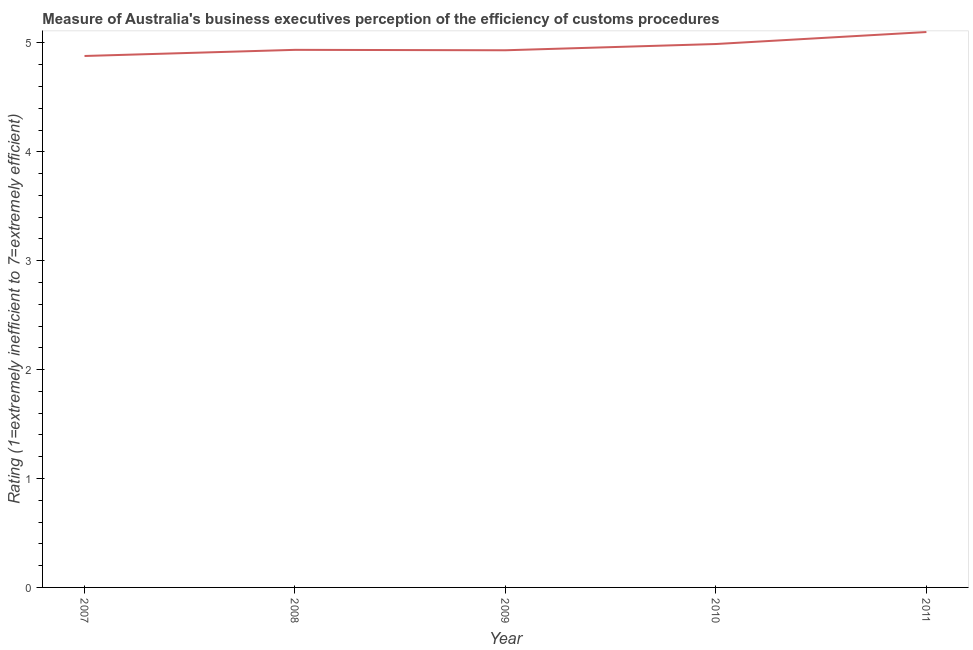What is the rating measuring burden of customs procedure in 2007?
Give a very brief answer. 4.88. Across all years, what is the minimum rating measuring burden of customs procedure?
Your answer should be very brief. 4.88. In which year was the rating measuring burden of customs procedure maximum?
Offer a very short reply. 2011. What is the sum of the rating measuring burden of customs procedure?
Make the answer very short. 24.84. What is the difference between the rating measuring burden of customs procedure in 2008 and 2010?
Your answer should be very brief. -0.05. What is the average rating measuring burden of customs procedure per year?
Provide a short and direct response. 4.97. What is the median rating measuring burden of customs procedure?
Make the answer very short. 4.94. In how many years, is the rating measuring burden of customs procedure greater than 0.6000000000000001 ?
Offer a very short reply. 5. Do a majority of the years between 2010 and 2008 (inclusive) have rating measuring burden of customs procedure greater than 2.8 ?
Give a very brief answer. No. What is the ratio of the rating measuring burden of customs procedure in 2008 to that in 2010?
Offer a terse response. 0.99. Is the rating measuring burden of customs procedure in 2009 less than that in 2011?
Provide a short and direct response. Yes. What is the difference between the highest and the second highest rating measuring burden of customs procedure?
Ensure brevity in your answer.  0.11. Is the sum of the rating measuring burden of customs procedure in 2007 and 2010 greater than the maximum rating measuring burden of customs procedure across all years?
Offer a terse response. Yes. What is the difference between the highest and the lowest rating measuring burden of customs procedure?
Your answer should be compact. 0.22. In how many years, is the rating measuring burden of customs procedure greater than the average rating measuring burden of customs procedure taken over all years?
Make the answer very short. 2. What is the difference between two consecutive major ticks on the Y-axis?
Offer a very short reply. 1. What is the title of the graph?
Your answer should be very brief. Measure of Australia's business executives perception of the efficiency of customs procedures. What is the label or title of the Y-axis?
Your response must be concise. Rating (1=extremely inefficient to 7=extremely efficient). What is the Rating (1=extremely inefficient to 7=extremely efficient) in 2007?
Make the answer very short. 4.88. What is the Rating (1=extremely inefficient to 7=extremely efficient) of 2008?
Offer a very short reply. 4.94. What is the Rating (1=extremely inefficient to 7=extremely efficient) in 2009?
Make the answer very short. 4.93. What is the Rating (1=extremely inefficient to 7=extremely efficient) in 2010?
Provide a short and direct response. 4.99. What is the difference between the Rating (1=extremely inefficient to 7=extremely efficient) in 2007 and 2008?
Offer a terse response. -0.06. What is the difference between the Rating (1=extremely inefficient to 7=extremely efficient) in 2007 and 2009?
Your response must be concise. -0.05. What is the difference between the Rating (1=extremely inefficient to 7=extremely efficient) in 2007 and 2010?
Offer a terse response. -0.11. What is the difference between the Rating (1=extremely inefficient to 7=extremely efficient) in 2007 and 2011?
Your answer should be compact. -0.22. What is the difference between the Rating (1=extremely inefficient to 7=extremely efficient) in 2008 and 2009?
Make the answer very short. 0. What is the difference between the Rating (1=extremely inefficient to 7=extremely efficient) in 2008 and 2010?
Your answer should be compact. -0.05. What is the difference between the Rating (1=extremely inefficient to 7=extremely efficient) in 2008 and 2011?
Keep it short and to the point. -0.16. What is the difference between the Rating (1=extremely inefficient to 7=extremely efficient) in 2009 and 2010?
Provide a succinct answer. -0.06. What is the difference between the Rating (1=extremely inefficient to 7=extremely efficient) in 2009 and 2011?
Give a very brief answer. -0.17. What is the difference between the Rating (1=extremely inefficient to 7=extremely efficient) in 2010 and 2011?
Offer a very short reply. -0.11. What is the ratio of the Rating (1=extremely inefficient to 7=extremely efficient) in 2007 to that in 2009?
Provide a short and direct response. 0.99. What is the ratio of the Rating (1=extremely inefficient to 7=extremely efficient) in 2008 to that in 2009?
Your answer should be very brief. 1. What is the ratio of the Rating (1=extremely inefficient to 7=extremely efficient) in 2008 to that in 2010?
Your response must be concise. 0.99. What is the ratio of the Rating (1=extremely inefficient to 7=extremely efficient) in 2008 to that in 2011?
Provide a succinct answer. 0.97. What is the ratio of the Rating (1=extremely inefficient to 7=extremely efficient) in 2009 to that in 2010?
Ensure brevity in your answer.  0.99. 